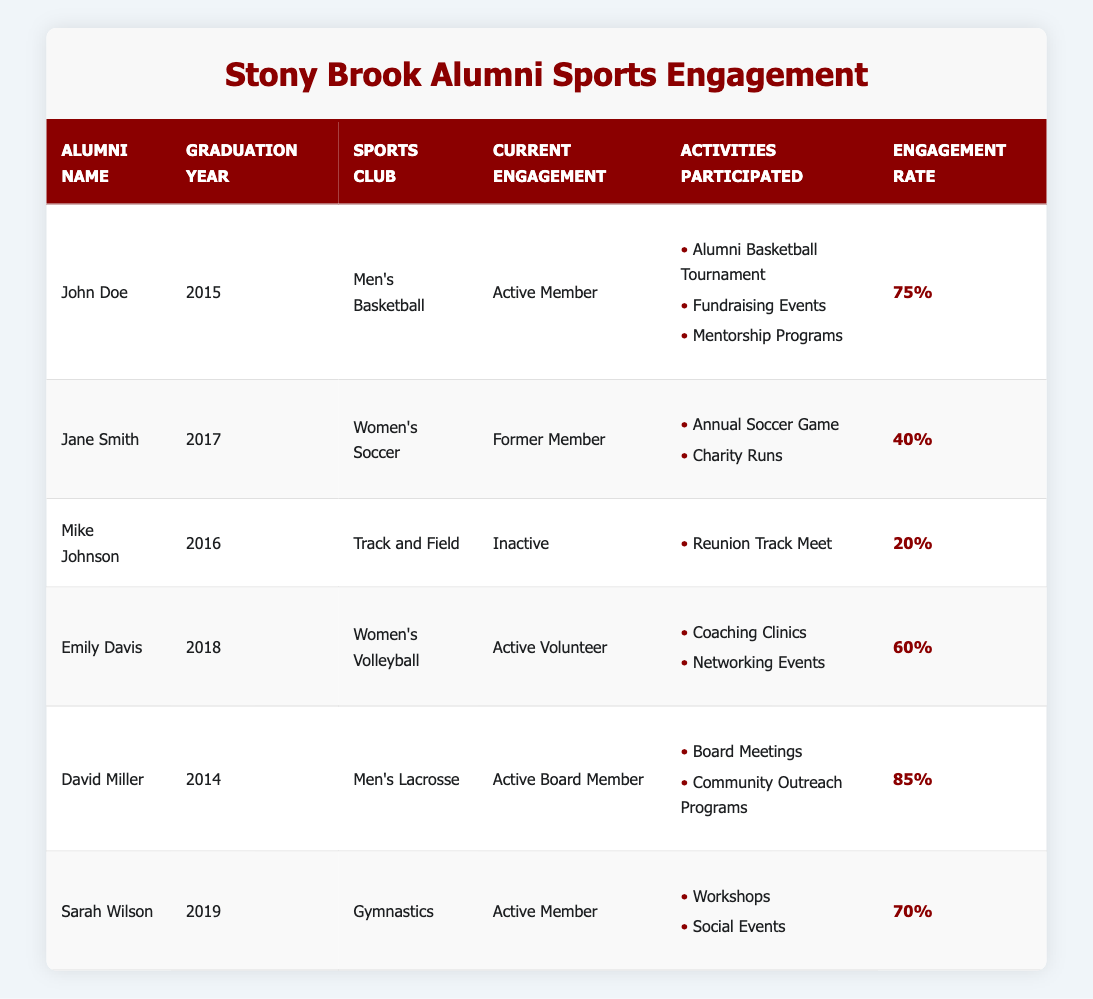What is the engagement rate of David Miller? The engagement rate for David Miller, who graduated in 2014 and is part of the Men's Lacrosse sports club, is listed in the table as 85%.
Answer: 85% Who is currently an active volunteer? The table shows that Emily Davis, a graduate of 2018 from the Women’s Volleyball club, is labeled as an Active Volunteer.
Answer: Emily Davis Which alumni has the highest engagement rate? By examining the engagement rates in the table, David Miller has the highest engagement rate at 85%.
Answer: David Miller What activities did Sarah Wilson participate in? The table lists the activities Sarah Wilson participated in as Workshops and Social Events under the Gymnastics club.
Answer: Workshops, Social Events Is Mike Johnson currently an active member? The table indicates that Mike Johnson is categorized as Inactive, which means he is not currently an active member.
Answer: No What is the average engagement rate of the alumni listed? The engagement rates are: 75%, 40%, 20%, 60%, 85%, and 70%. Sum these rates: 75 + 40 + 20 + 60 + 85 + 70 = 350. Divide by the number of alumni (6) to find the average: 350 / 6 = 58.33%.
Answer: 58.33% How many alumni are currently active members? The active members in the table are John Doe, Sarah Wilson, and Emily Davis, totaling to 3 active members.
Answer: 3 Which sport club has the lowest engagement rate? Comparing engagement rates, Mike Johnson from Track and Field has the lowest rate of 20% listed in the table.
Answer: Track and Field Did any alumni participate in charity events? Analyzing the table, Jane Smith is noted to have participated in Charity Runs, which qualifies as a charity event.
Answer: Yes How many sports clubs are represented in this table? The table lists six unique sports clubs: Men's Basketball, Women's Soccer, Track and Field, Women’s Volleyball, Men's Lacrosse, and Gymnastics, making it a total of 6 clubs represented.
Answer: 6 